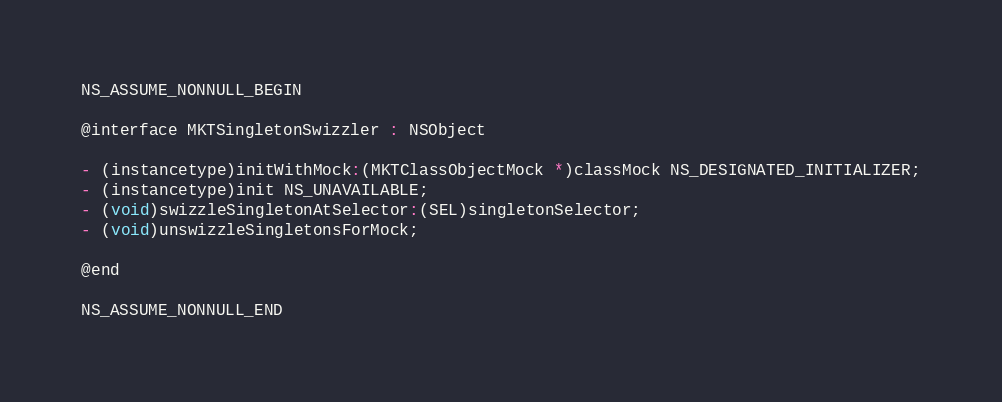<code> <loc_0><loc_0><loc_500><loc_500><_C_>NS_ASSUME_NONNULL_BEGIN

@interface MKTSingletonSwizzler : NSObject

- (instancetype)initWithMock:(MKTClassObjectMock *)classMock NS_DESIGNATED_INITIALIZER;
- (instancetype)init NS_UNAVAILABLE;
- (void)swizzleSingletonAtSelector:(SEL)singletonSelector;
- (void)unswizzleSingletonsForMock;

@end

NS_ASSUME_NONNULL_END
</code> 